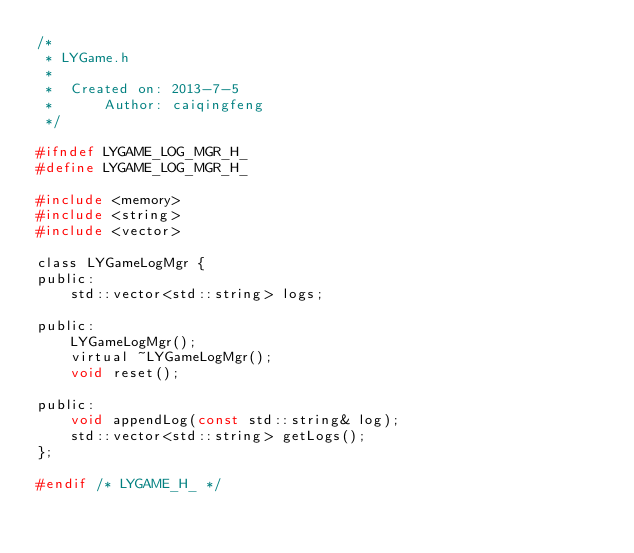<code> <loc_0><loc_0><loc_500><loc_500><_C_>/*
 * LYGame.h
 *
 *  Created on: 2013-7-5
 *      Author: caiqingfeng
 */

#ifndef LYGAME_LOG_MGR_H_
#define LYGAME_LOG_MGR_H_

#include <memory>
#include <string>
#include <vector>

class LYGameLogMgr {
public:
	std::vector<std::string> logs;

public:
	LYGameLogMgr();
	virtual ~LYGameLogMgr();
	void reset();

public:
	void appendLog(const std::string& log);
	std::vector<std::string> getLogs();
};

#endif /* LYGAME_H_ */
</code> 